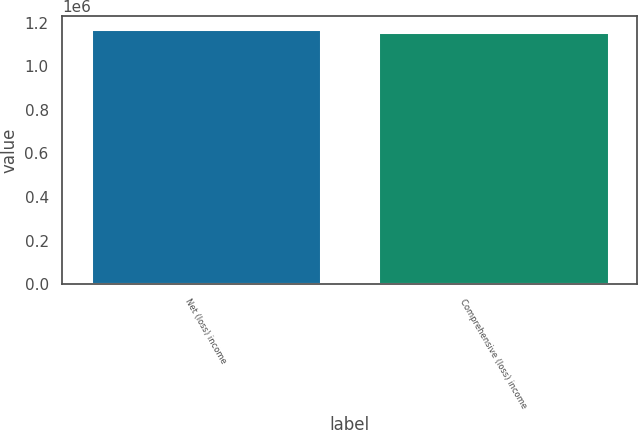Convert chart to OTSL. <chart><loc_0><loc_0><loc_500><loc_500><bar_chart><fcel>Net (loss) income<fcel>Comprehensive (loss) income<nl><fcel>1.17284e+06<fcel>1.15924e+06<nl></chart> 